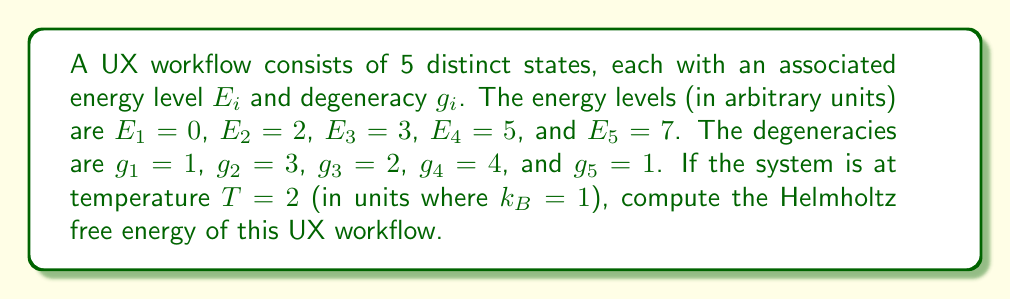Give your solution to this math problem. To compute the Helmholtz free energy, we need to follow these steps:

1. Calculate the partition function $Z$:
   $$Z = \sum_{i=1}^5 g_i e^{-E_i/T}$$

2. Substitute the given values:
   $$Z = 1 \cdot e^{-0/2} + 3 \cdot e^{-2/2} + 2 \cdot e^{-3/2} + 4 \cdot e^{-5/2} + 1 \cdot e^{-7/2}$$

3. Simplify:
   $$Z = 1 + 3e^{-1} + 2e^{-3/2} + 4e^{-5/2} + e^{-7/2}$$

4. Calculate the numerical value of $Z$:
   $$Z \approx 4.5229$$

5. Use the formula for Helmholtz free energy:
   $$F = -T \ln Z$$

6. Substitute the values:
   $$F = -2 \ln(4.5229)$$

7. Calculate the final result:
   $$F \approx -3.0184$$
Answer: $F \approx -3.0184$ (in arbitrary energy units) 